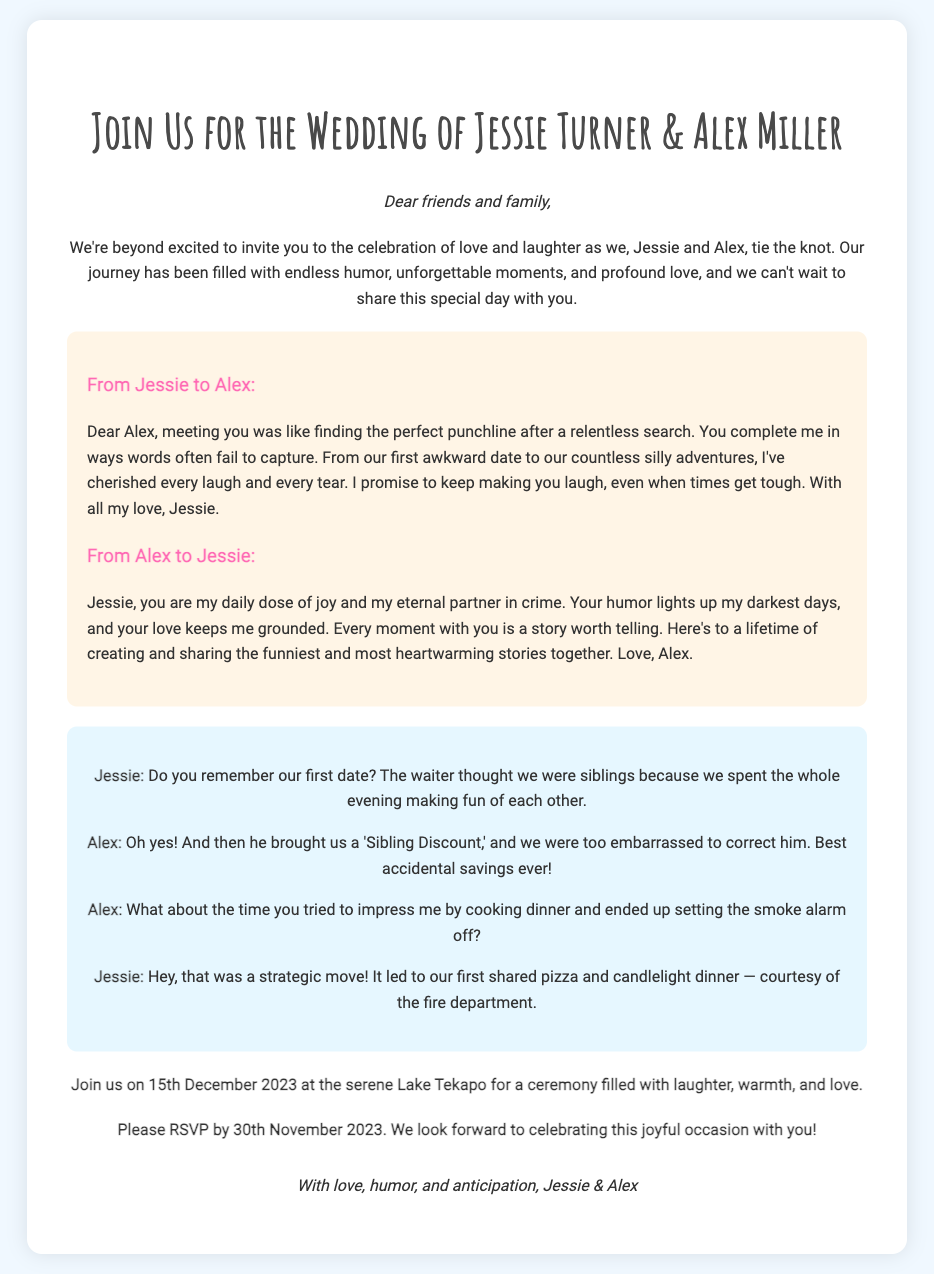What are the names of the couple getting married? The names of the couple are mentioned in the title, Jessie Turner and Alex Miller.
Answer: Jessie Turner & Alex Miller What is the wedding date? The wedding date is explicitly stated in the document as the day of the ceremony.
Answer: 15th December 2023 Where is the wedding taking place? The location of the wedding is mentioned in the details about the ceremony and is set at a specific place.
Answer: Lake Tekapo What is the RSVP deadline? The RSVP deadline is clearly stated in the invitation, indicating when responses are due.
Answer: 30th November 2023 What humorous incident is mentioned about their first date? The couple recalls a specific humorous event from their first date that is highlighted in their interactions.
Answer: Sibling Discount Who wrote the first love letter? The document attributes the first love letter to one of the individuals in the couple.
Answer: Jessie What style is the document formatted with? The design style is characterized in the body text, indicating the overall aesthetic of the invitation.
Answer: Heartfelt and humorous What theme does the invitation reflect? The overall theme of the invitation is suggested through the language and content used throughout the document.
Answer: Love and laughter What type of humor do Jessie and Alex share? The document illustrates the nature of their humor through examples in their interactions.
Answer: Light-hearted teasing 